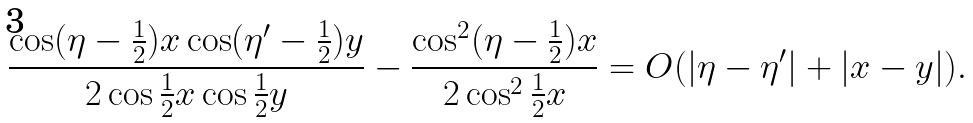<formula> <loc_0><loc_0><loc_500><loc_500>\frac { \cos ( \eta - \frac { 1 } { 2 } ) x \cos ( \eta ^ { \prime } - \frac { 1 } { 2 } ) y } { 2 \cos \frac { 1 } { 2 } x \cos \frac { 1 } { 2 } y } - \frac { \cos ^ { 2 } ( \eta - \frac { 1 } { 2 } ) x } { 2 \cos ^ { 2 } \frac { 1 } { 2 } x } = O ( | \eta - \eta ^ { \prime } | + | x - y | ) .</formula> 